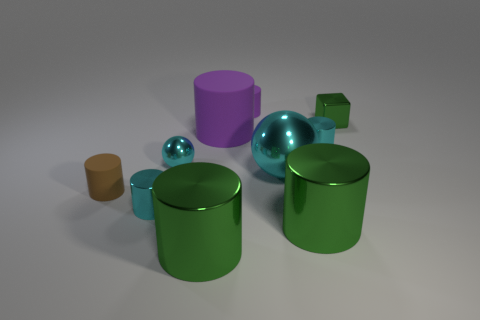What number of big shiny things are there?
Ensure brevity in your answer.  3. There is another tiny object that is the same material as the brown thing; what is its shape?
Provide a short and direct response. Cylinder. Do the block and the big cylinder that is right of the large cyan metallic ball have the same color?
Your answer should be very brief. Yes. Is the number of tiny cyan metallic cylinders that are behind the small shiny sphere less than the number of tiny brown matte objects?
Your answer should be very brief. No. There is a cyan cylinder on the right side of the small purple thing; what material is it?
Offer a very short reply. Metal. How many other things are the same size as the green cube?
Give a very brief answer. 5. Do the green block and the cyan cylinder left of the large rubber thing have the same size?
Make the answer very short. Yes. There is a tiny purple matte thing behind the cyan metal cylinder that is on the left side of the small cyan cylinder behind the big cyan metal sphere; what is its shape?
Your answer should be very brief. Cylinder. Are there fewer cubes than big blocks?
Make the answer very short. No. Are there any cyan balls on the left side of the large rubber cylinder?
Offer a terse response. Yes. 